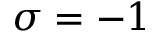Convert formula to latex. <formula><loc_0><loc_0><loc_500><loc_500>\sigma = - 1</formula> 